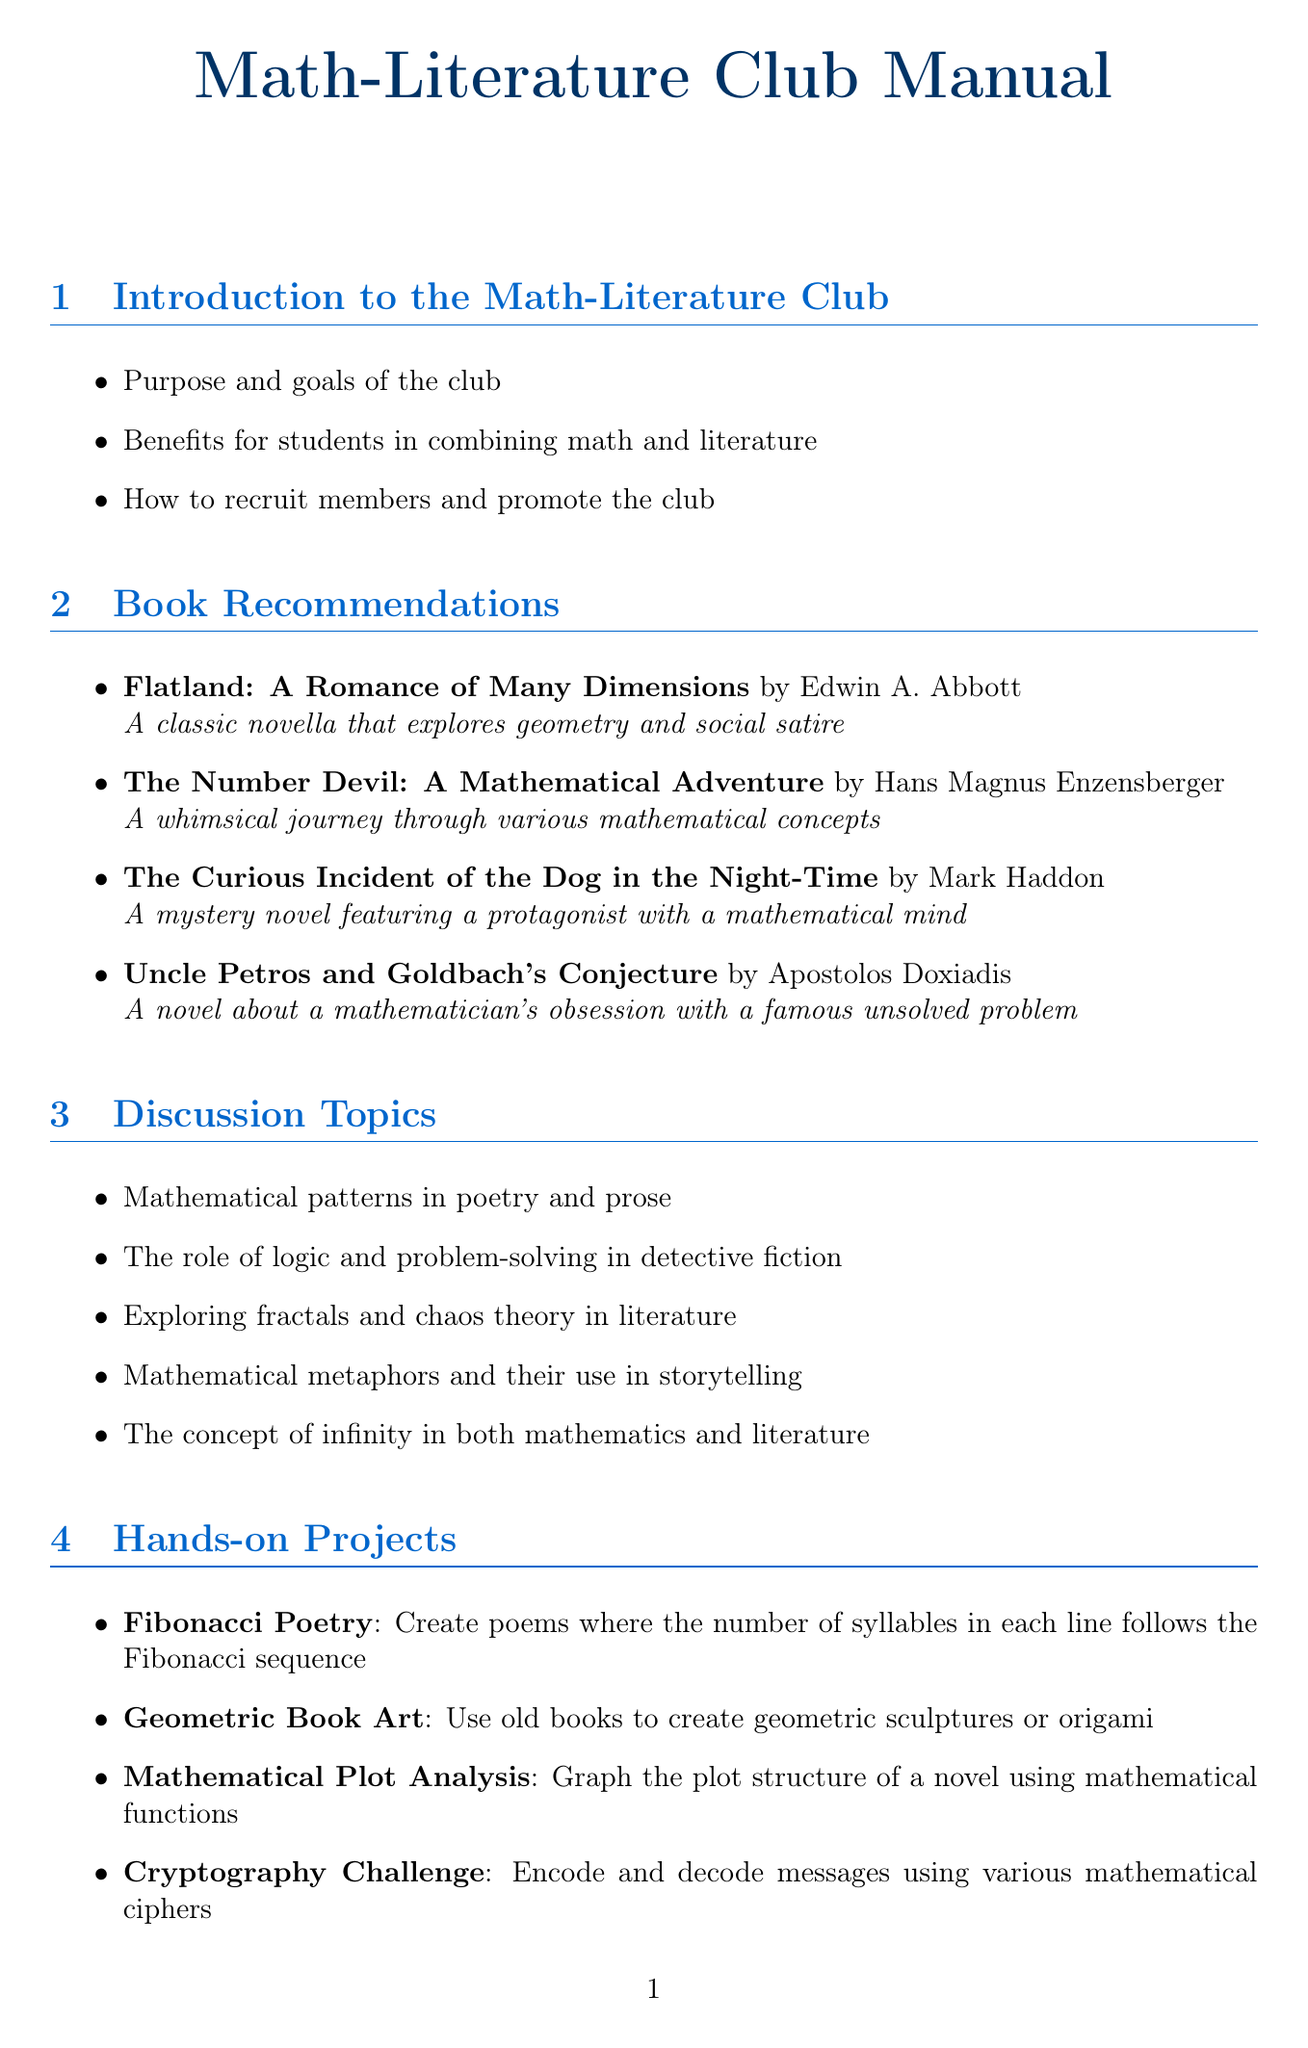What is the title of the first section in the manual? The title of the first section is "Introduction to the Math-Literature Club."
Answer: Introduction to the Math-Literature Club Who is the author of "The Number Devil"? This book is authored by Hans Magnus Enzensberger.
Answer: Hans Magnus Enzensberger Name one discussion topic related to mathematics in literature. The document lists topics such as "The role of logic and problem-solving in detective fiction."
Answer: The role of logic and problem-solving in detective fiction What is one hands-on project mentioned in the document? The manual suggests various projects, including "Fibonacci Poetry."
Answer: Fibonacci Poetry How many book recommendations are listed in the manual? There are four specific book recommendations provided in the document.
Answer: Four What is the purpose of the Math-Literature Club? The document states the purpose is to combine math and literature for educational benefits.
Answer: Combine math and literature What is a suggested role in the club meetings? The manual suggests roles and responsibilities for club members.
Answer: Roles and responsibilities for club members What method is mentioned for evaluating the club's impact? Methods to evaluate the impact of the club on students' math and literature skills are discussed.
Answer: Impact on students' math and literature skills 